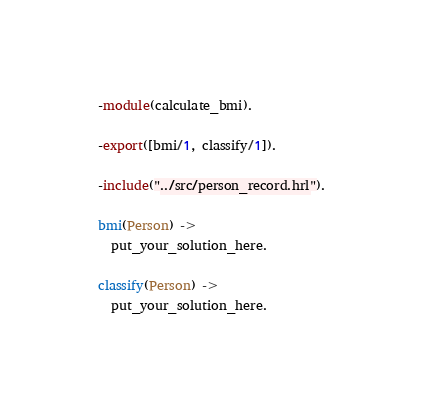<code> <loc_0><loc_0><loc_500><loc_500><_Erlang_>-module(calculate_bmi).

-export([bmi/1, classify/1]).

-include("../src/person_record.hrl").

bmi(Person) ->
  put_your_solution_here.

classify(Person) ->
  put_your_solution_here.
</code> 